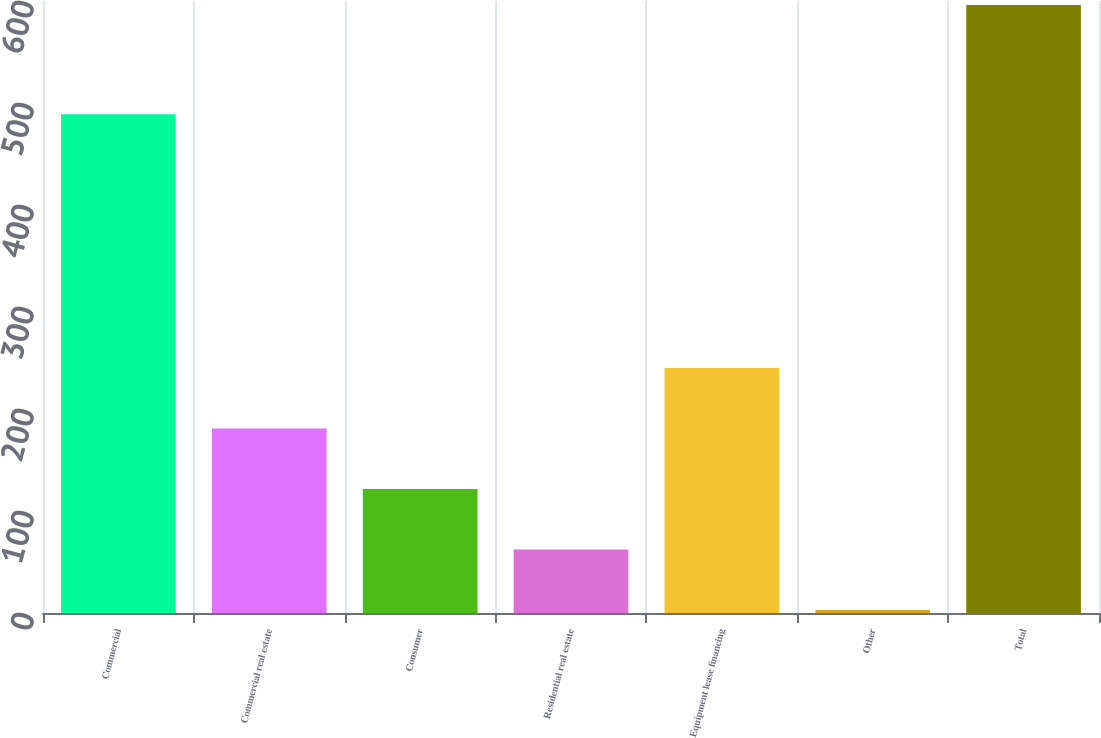<chart> <loc_0><loc_0><loc_500><loc_500><bar_chart><fcel>Commercial<fcel>Commercial real estate<fcel>Consumer<fcel>Residential real estate<fcel>Equipment lease financing<fcel>Other<fcel>Total<nl><fcel>489<fcel>180.9<fcel>121.6<fcel>62.3<fcel>240.2<fcel>3<fcel>596<nl></chart> 